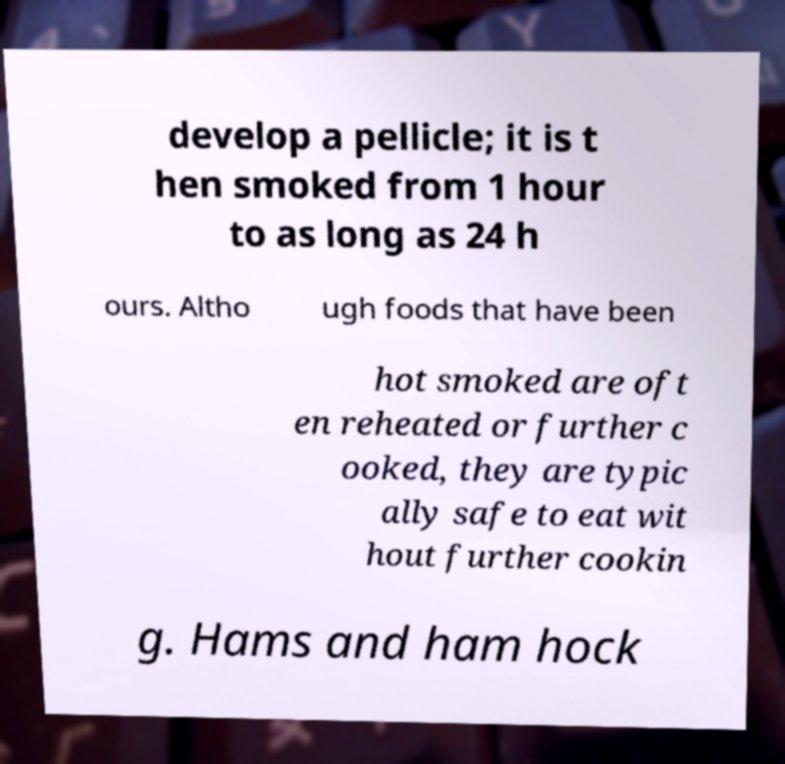For documentation purposes, I need the text within this image transcribed. Could you provide that? develop a pellicle; it is t hen smoked from 1 hour to as long as 24 h ours. Altho ugh foods that have been hot smoked are oft en reheated or further c ooked, they are typic ally safe to eat wit hout further cookin g. Hams and ham hock 